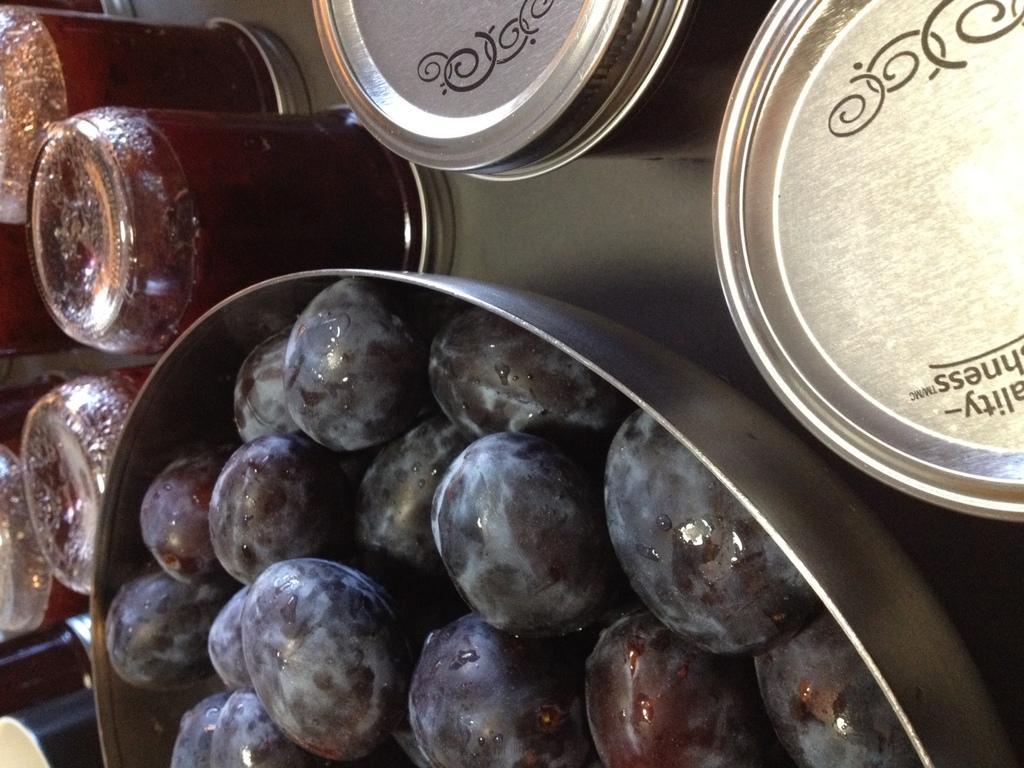Can you describe this image briefly? In this image we can see grapes in a bowl. In the background we can also see juice jars placed on the surface. 